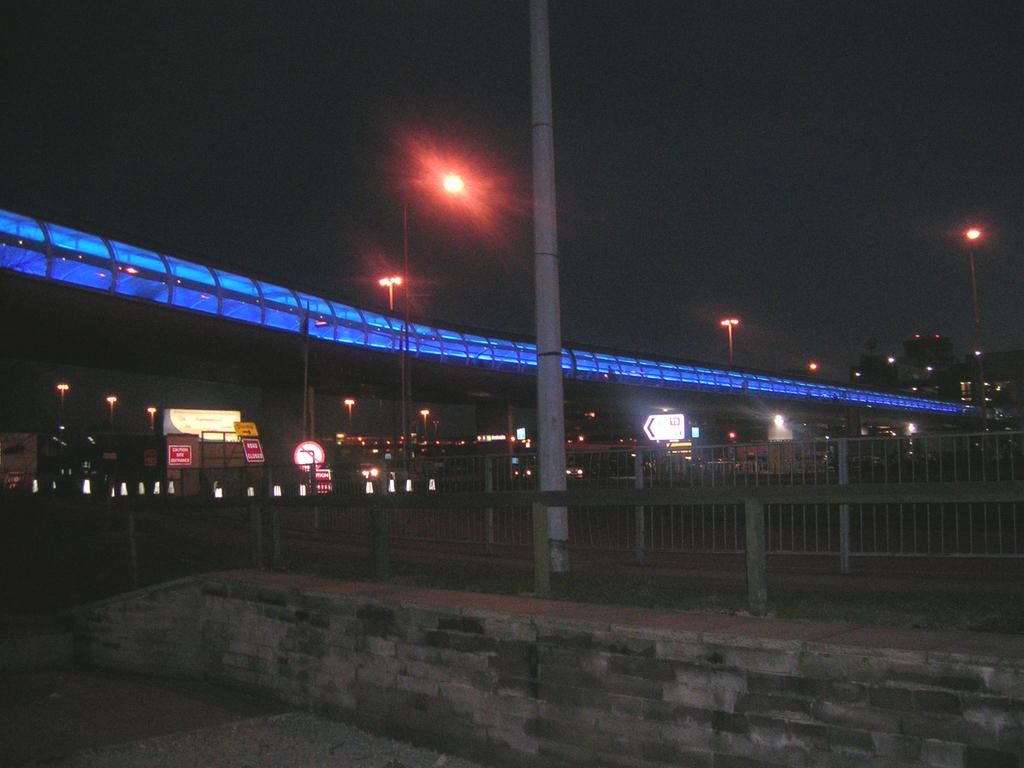What type of structure is at the bottom of the image? There is fencing at the bottom of the image. What can be seen behind the fencing? Poles, banners, lights, sign boards, and a bridge are visible behind the fencing. What is in the background of the image? Buildings are visible in the background. What is the opinion of the ghost in the image? There is no ghost present in the image, so it is not possible to determine its opinion. 